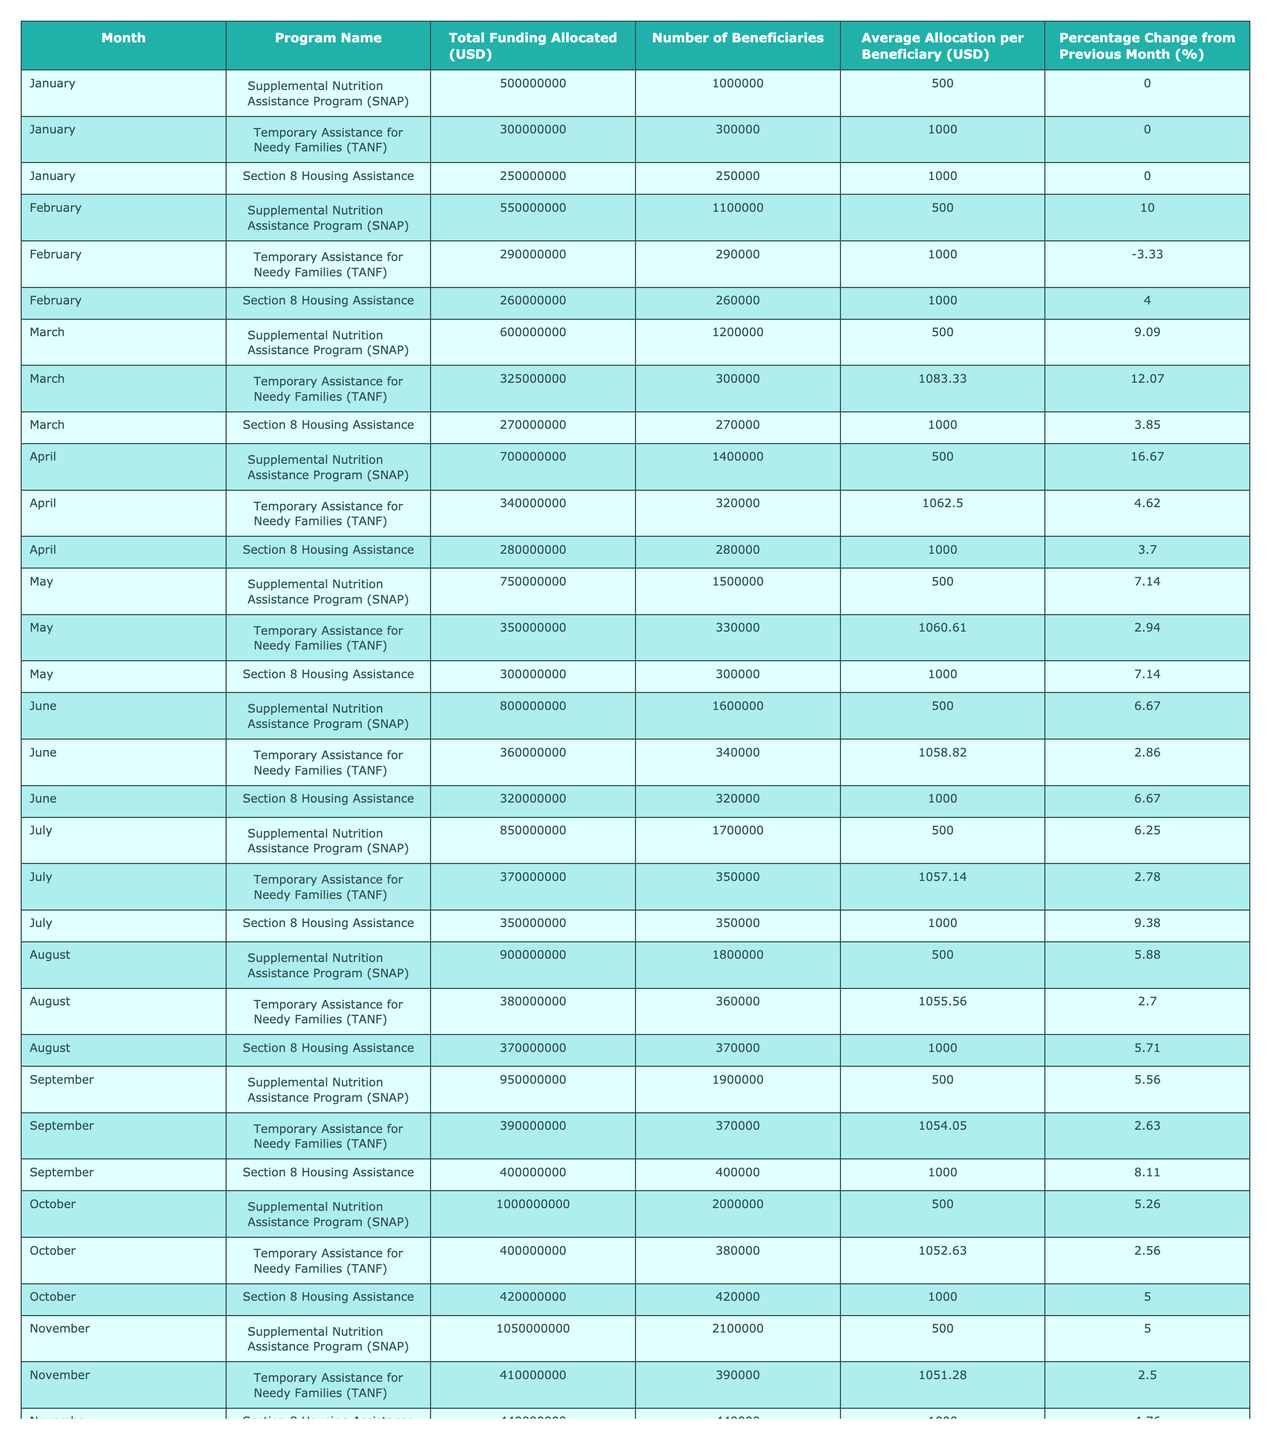What was the total funding allocated to the Temporary Assistance for Needy Families (TANF) program in March? For March, the table shows that the total funding allocated to the TANF program was 325,000,000 USD.
Answer: 325,000,000 USD In which month did the Supplemental Nutrition Assistance Program (SNAP) see the highest funding allocation, and what was that amount? The highest funding allocation for SNAP was in December, with 1,100,000,000 USD.
Answer: December, 1,100,000,000 USD What is the average allocation per beneficiary for Section 8 Housing Assistance in June? In June, the average allocation per beneficiary for Section 8 Housing Assistance was 1,000 USD as shown in the table.
Answer: 1,000 USD Which program consistently had an average allocation of 500 USD per beneficiary? The SNAP program consistently had an average allocation of 500 USD per beneficiary throughout the year.
Answer: SNAP What was the percentage change in funding from January to February for the Temporary Assistance for Needy Families (TANF) program? The percentage change for TANF from January (300,000,000 USD) to February (290,000,000 USD) was a decrease of 3.33%.
Answer: -3.33% What was the total funding allocated to all programs in May? The total funding allocated in May is calculated by summing up the amounts: 750,000,000 (SNAP) + 350,000,000 (TANF) + 300,000,000 (Section 8) = 1,400,000,000 USD.
Answer: 1,400,000,000 USD Did the number of beneficiaries for the Supplemental Nutrition Assistance Program (SNAP) increase or decrease from October to November? The number of beneficiaries increased from 2,000,000 in October to 2,100,000 in November for SNAP.
Answer: Increased Which month recorded the highest number of beneficiaries for the Temporary Assistance for Needy Families (TANF) program, and how many beneficiaries were there? The month with the highest number of beneficiaries for TANF was December, with 400,000 beneficiaries.
Answer: December, 400,000 What was the change in average allocation per beneficiary for Section 8 Housing Assistance from April to October? In April, the average allocation was 1,000 USD, and in October, it remained 1,000 USD. Thus, there was no change.
Answer: No change Calculate the total funding allocated to Section 8 Housing Assistance for the entire year. The total funding for Section 8 is calculated as follows: 250,000,000 + 260,000,000 + 270,000,000 + 280,000,000 + 300,000,000 + 320,000,000 + 350,000,000 + 370,000,000 + 400,000,000 + 420,000,000 + 440,000,000 + 460,000,000 = 3,730,000,000 USD.
Answer: 3,730,000,000 USD What is the overall trend in the percentage change of funding across the programs from January to December? The overall trend shows that the percentage change in funding decreased steadily, with SNAP having significant increases in the earlier months and small changes later, while TANF consistently showed a decrease.
Answer: Decreased trend 